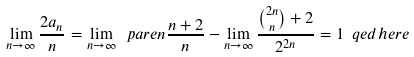<formula> <loc_0><loc_0><loc_500><loc_500>\lim _ { n \to \infty } \frac { 2 a _ { n } } { n } = \lim _ { n \to \infty } \ p a r e n { \frac { n + 2 } { n } } - \lim _ { n \to \infty } \frac { \binom { 2 n } { n } + 2 } { 2 ^ { 2 n } } = 1 \ q e d h e r e</formula> 